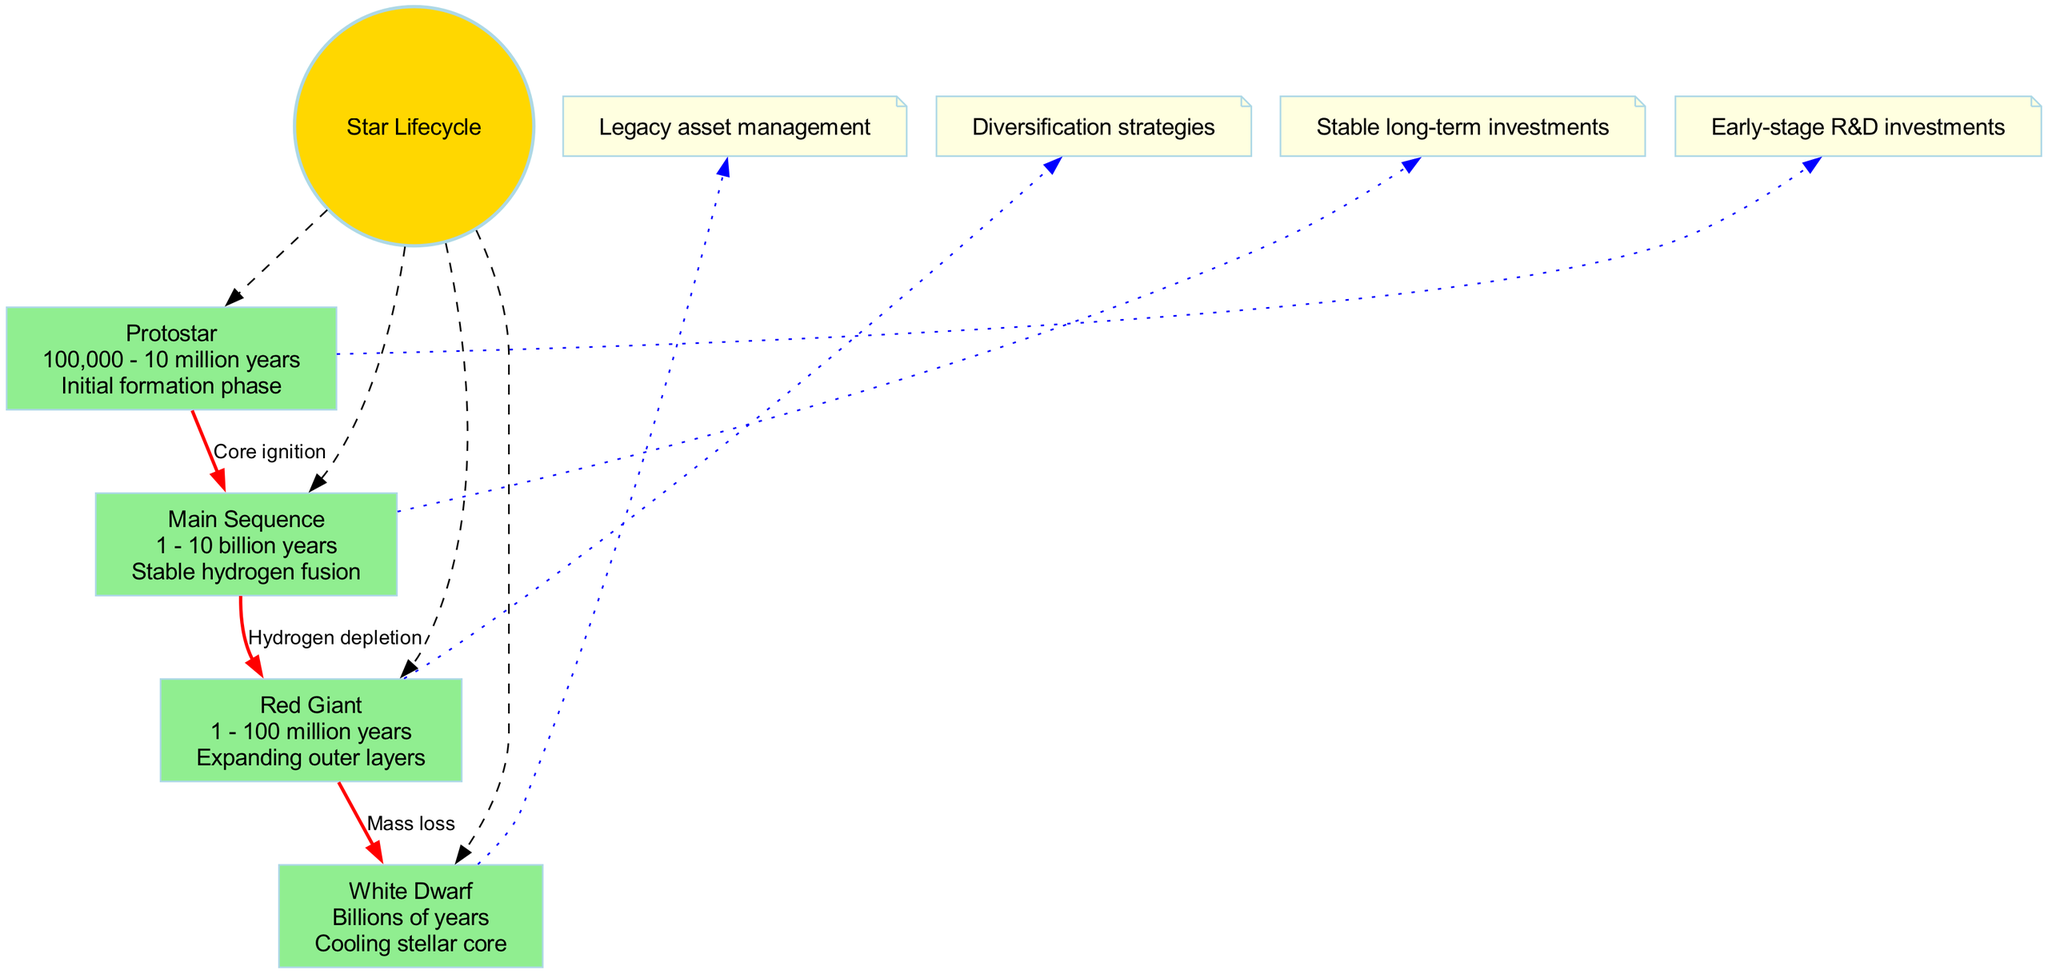What is the duration of the Main Sequence stage? The diagram indicates that the duration of the Main Sequence stage is "1 - 10 billion years."
Answer: 1 - 10 billion years How many total stages are represented in the diagram? The diagram displays a total of 4 stages: Protostar, Main Sequence, Red Giant, and White Dwarf.
Answer: 4 What connects the Protostar to the Main Sequence? The connection between Protostar and Main Sequence is labeled as "Core ignition."
Answer: Core ignition What is the opportunity for investment during the White Dwarf stage? The investment opportunity indicated for the White Dwarf stage is "Legacy asset management."
Answer: Legacy asset management Which stage has the longest duration? The White Dwarf stage is stated to last for "Billions of years," making it the longest in duration.
Answer: Billions of years What stage follows after the Red Giant stage? According to the diagram, the stage that follows the Red Giant is the White Dwarf.
Answer: White Dwarf What kind of investment opportunities are suggested for the Main Sequence stage? The diagram suggests "Stable long-term investments" for the Main Sequence stage as the opportunity.
Answer: Stable long-term investments Which stage is associated with "Hydrogen depletion"? The Red Giant stage is associated with the connection labeled "Hydrogen depletion."
Answer: Red Giant What are the connections leading from the Red Giant stage? The Red Giant stage connects to the White Dwarf stage, labeled as "Mass loss."
Answer: Mass loss 